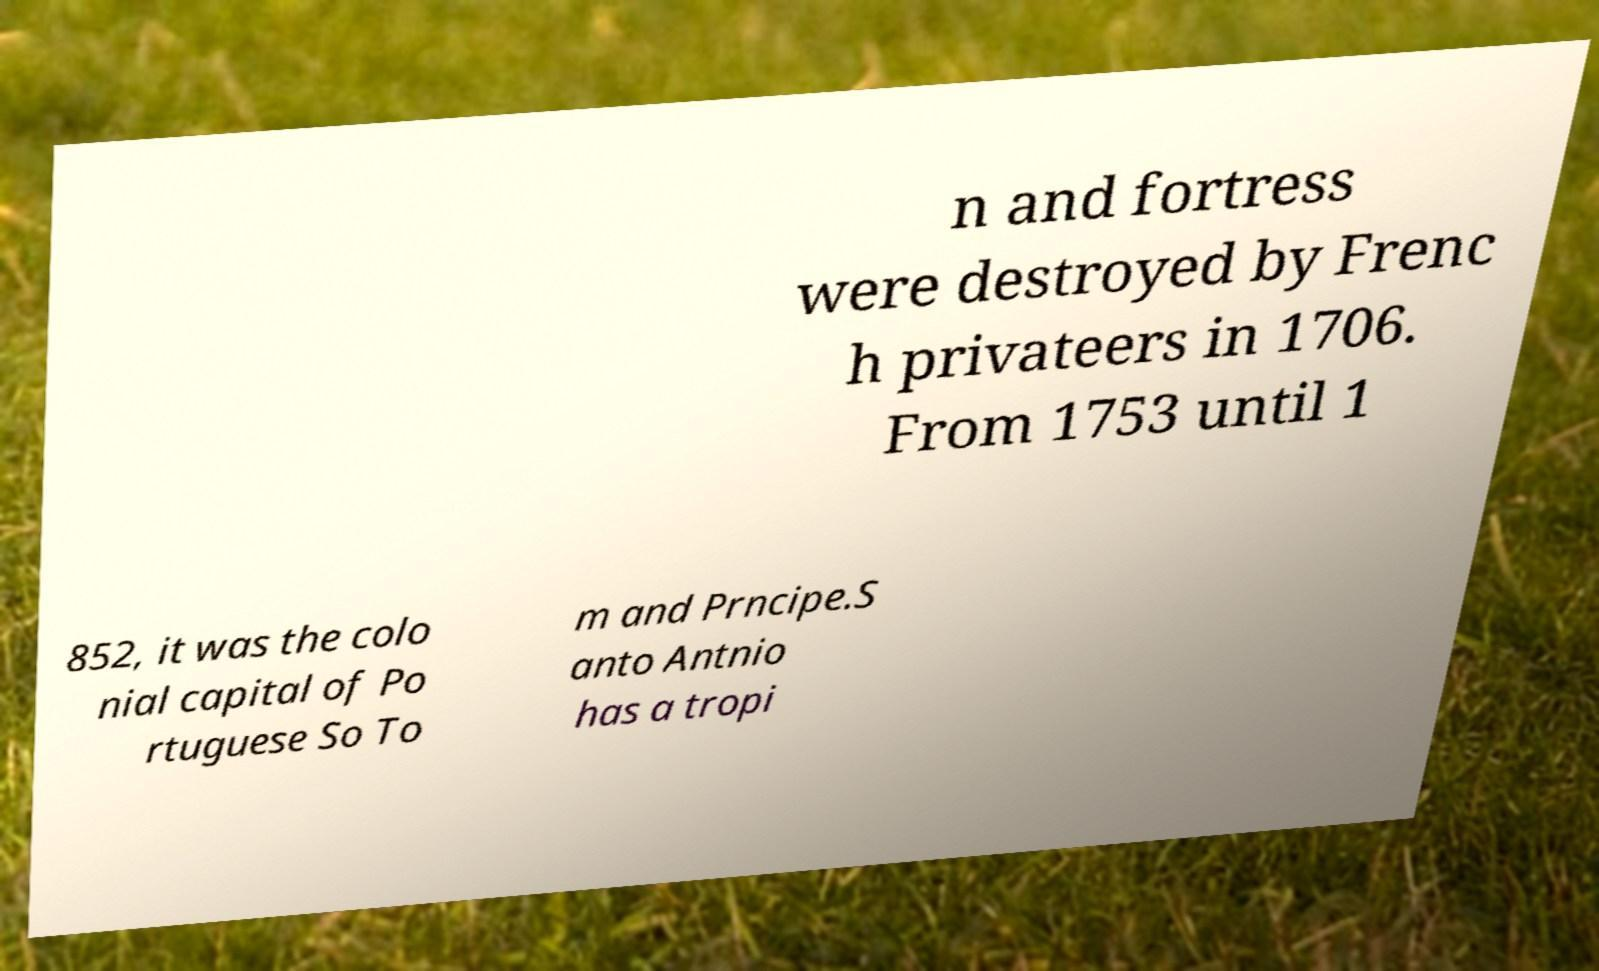What messages or text are displayed in this image? I need them in a readable, typed format. n and fortress were destroyed by Frenc h privateers in 1706. From 1753 until 1 852, it was the colo nial capital of Po rtuguese So To m and Prncipe.S anto Antnio has a tropi 